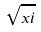Convert formula to latex. <formula><loc_0><loc_0><loc_500><loc_500>\sqrt { x i }</formula> 